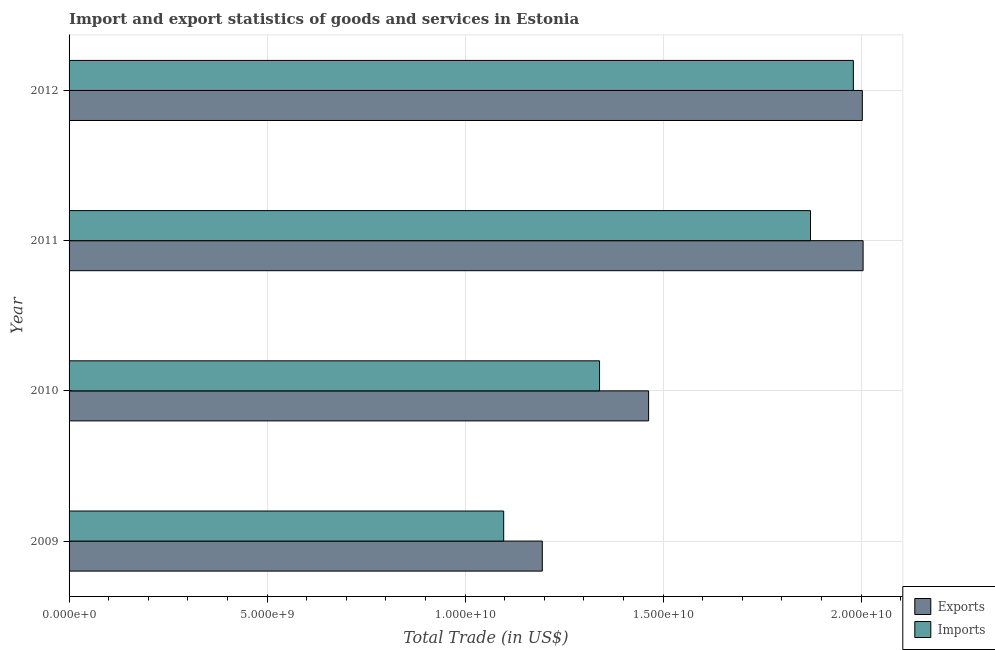How many different coloured bars are there?
Your answer should be very brief. 2. Are the number of bars per tick equal to the number of legend labels?
Your answer should be very brief. Yes. Are the number of bars on each tick of the Y-axis equal?
Make the answer very short. Yes. How many bars are there on the 4th tick from the bottom?
Make the answer very short. 2. In how many cases, is the number of bars for a given year not equal to the number of legend labels?
Your answer should be very brief. 0. What is the imports of goods and services in 2010?
Make the answer very short. 1.34e+1. Across all years, what is the maximum export of goods and services?
Your answer should be very brief. 2.01e+1. Across all years, what is the minimum export of goods and services?
Keep it short and to the point. 1.19e+1. In which year was the imports of goods and services maximum?
Provide a succinct answer. 2012. In which year was the imports of goods and services minimum?
Offer a very short reply. 2009. What is the total imports of goods and services in the graph?
Your answer should be very brief. 6.29e+1. What is the difference between the imports of goods and services in 2009 and that in 2012?
Ensure brevity in your answer.  -8.83e+09. What is the difference between the imports of goods and services in 2009 and the export of goods and services in 2010?
Your response must be concise. -3.66e+09. What is the average imports of goods and services per year?
Give a very brief answer. 1.57e+1. In the year 2009, what is the difference between the imports of goods and services and export of goods and services?
Provide a succinct answer. -9.75e+08. In how many years, is the imports of goods and services greater than 5000000000 US$?
Ensure brevity in your answer.  4. What is the ratio of the imports of goods and services in 2010 to that in 2012?
Provide a succinct answer. 0.68. Is the export of goods and services in 2010 less than that in 2011?
Your answer should be very brief. Yes. Is the difference between the export of goods and services in 2009 and 2010 greater than the difference between the imports of goods and services in 2009 and 2010?
Ensure brevity in your answer.  No. What is the difference between the highest and the second highest export of goods and services?
Offer a terse response. 1.93e+07. What is the difference between the highest and the lowest export of goods and services?
Ensure brevity in your answer.  8.10e+09. In how many years, is the imports of goods and services greater than the average imports of goods and services taken over all years?
Provide a succinct answer. 2. What does the 2nd bar from the top in 2009 represents?
Offer a very short reply. Exports. What does the 2nd bar from the bottom in 2012 represents?
Ensure brevity in your answer.  Imports. Are all the bars in the graph horizontal?
Keep it short and to the point. Yes. Does the graph contain any zero values?
Provide a short and direct response. No. Does the graph contain grids?
Your response must be concise. Yes. How many legend labels are there?
Your answer should be compact. 2. How are the legend labels stacked?
Give a very brief answer. Vertical. What is the title of the graph?
Your answer should be very brief. Import and export statistics of goods and services in Estonia. What is the label or title of the X-axis?
Make the answer very short. Total Trade (in US$). What is the label or title of the Y-axis?
Ensure brevity in your answer.  Year. What is the Total Trade (in US$) of Exports in 2009?
Offer a terse response. 1.19e+1. What is the Total Trade (in US$) in Imports in 2009?
Keep it short and to the point. 1.10e+1. What is the Total Trade (in US$) in Exports in 2010?
Your answer should be compact. 1.46e+1. What is the Total Trade (in US$) of Imports in 2010?
Give a very brief answer. 1.34e+1. What is the Total Trade (in US$) of Exports in 2011?
Give a very brief answer. 2.01e+1. What is the Total Trade (in US$) in Imports in 2011?
Give a very brief answer. 1.87e+1. What is the Total Trade (in US$) in Exports in 2012?
Your answer should be compact. 2.00e+1. What is the Total Trade (in US$) in Imports in 2012?
Keep it short and to the point. 1.98e+1. Across all years, what is the maximum Total Trade (in US$) of Exports?
Give a very brief answer. 2.01e+1. Across all years, what is the maximum Total Trade (in US$) in Imports?
Ensure brevity in your answer.  1.98e+1. Across all years, what is the minimum Total Trade (in US$) of Exports?
Make the answer very short. 1.19e+1. Across all years, what is the minimum Total Trade (in US$) of Imports?
Give a very brief answer. 1.10e+1. What is the total Total Trade (in US$) in Exports in the graph?
Your answer should be compact. 6.67e+1. What is the total Total Trade (in US$) of Imports in the graph?
Keep it short and to the point. 6.29e+1. What is the difference between the Total Trade (in US$) of Exports in 2009 and that in 2010?
Give a very brief answer. -2.68e+09. What is the difference between the Total Trade (in US$) of Imports in 2009 and that in 2010?
Provide a short and direct response. -2.42e+09. What is the difference between the Total Trade (in US$) of Exports in 2009 and that in 2011?
Provide a short and direct response. -8.10e+09. What is the difference between the Total Trade (in US$) of Imports in 2009 and that in 2011?
Give a very brief answer. -7.75e+09. What is the difference between the Total Trade (in US$) of Exports in 2009 and that in 2012?
Provide a succinct answer. -8.08e+09. What is the difference between the Total Trade (in US$) of Imports in 2009 and that in 2012?
Your response must be concise. -8.83e+09. What is the difference between the Total Trade (in US$) in Exports in 2010 and that in 2011?
Give a very brief answer. -5.42e+09. What is the difference between the Total Trade (in US$) in Imports in 2010 and that in 2011?
Offer a terse response. -5.33e+09. What is the difference between the Total Trade (in US$) in Exports in 2010 and that in 2012?
Provide a succinct answer. -5.40e+09. What is the difference between the Total Trade (in US$) of Imports in 2010 and that in 2012?
Give a very brief answer. -6.41e+09. What is the difference between the Total Trade (in US$) in Exports in 2011 and that in 2012?
Your answer should be very brief. 1.93e+07. What is the difference between the Total Trade (in US$) in Imports in 2011 and that in 2012?
Make the answer very short. -1.08e+09. What is the difference between the Total Trade (in US$) of Exports in 2009 and the Total Trade (in US$) of Imports in 2010?
Your answer should be very brief. -1.45e+09. What is the difference between the Total Trade (in US$) of Exports in 2009 and the Total Trade (in US$) of Imports in 2011?
Provide a short and direct response. -6.77e+09. What is the difference between the Total Trade (in US$) in Exports in 2009 and the Total Trade (in US$) in Imports in 2012?
Provide a succinct answer. -7.85e+09. What is the difference between the Total Trade (in US$) of Exports in 2010 and the Total Trade (in US$) of Imports in 2011?
Give a very brief answer. -4.09e+09. What is the difference between the Total Trade (in US$) in Exports in 2010 and the Total Trade (in US$) in Imports in 2012?
Your answer should be compact. -5.17e+09. What is the difference between the Total Trade (in US$) of Exports in 2011 and the Total Trade (in US$) of Imports in 2012?
Keep it short and to the point. 2.46e+08. What is the average Total Trade (in US$) of Exports per year?
Keep it short and to the point. 1.67e+1. What is the average Total Trade (in US$) of Imports per year?
Your answer should be compact. 1.57e+1. In the year 2009, what is the difference between the Total Trade (in US$) in Exports and Total Trade (in US$) in Imports?
Your answer should be compact. 9.75e+08. In the year 2010, what is the difference between the Total Trade (in US$) in Exports and Total Trade (in US$) in Imports?
Make the answer very short. 1.24e+09. In the year 2011, what is the difference between the Total Trade (in US$) of Exports and Total Trade (in US$) of Imports?
Your answer should be very brief. 1.33e+09. In the year 2012, what is the difference between the Total Trade (in US$) of Exports and Total Trade (in US$) of Imports?
Your response must be concise. 2.26e+08. What is the ratio of the Total Trade (in US$) of Exports in 2009 to that in 2010?
Ensure brevity in your answer.  0.82. What is the ratio of the Total Trade (in US$) in Imports in 2009 to that in 2010?
Provide a succinct answer. 0.82. What is the ratio of the Total Trade (in US$) in Exports in 2009 to that in 2011?
Make the answer very short. 0.6. What is the ratio of the Total Trade (in US$) in Imports in 2009 to that in 2011?
Keep it short and to the point. 0.59. What is the ratio of the Total Trade (in US$) in Exports in 2009 to that in 2012?
Your response must be concise. 0.6. What is the ratio of the Total Trade (in US$) of Imports in 2009 to that in 2012?
Your response must be concise. 0.55. What is the ratio of the Total Trade (in US$) in Exports in 2010 to that in 2011?
Offer a very short reply. 0.73. What is the ratio of the Total Trade (in US$) of Imports in 2010 to that in 2011?
Offer a terse response. 0.72. What is the ratio of the Total Trade (in US$) of Exports in 2010 to that in 2012?
Keep it short and to the point. 0.73. What is the ratio of the Total Trade (in US$) of Imports in 2010 to that in 2012?
Offer a very short reply. 0.68. What is the ratio of the Total Trade (in US$) of Imports in 2011 to that in 2012?
Keep it short and to the point. 0.95. What is the difference between the highest and the second highest Total Trade (in US$) of Exports?
Make the answer very short. 1.93e+07. What is the difference between the highest and the second highest Total Trade (in US$) in Imports?
Your response must be concise. 1.08e+09. What is the difference between the highest and the lowest Total Trade (in US$) in Exports?
Your response must be concise. 8.10e+09. What is the difference between the highest and the lowest Total Trade (in US$) in Imports?
Offer a terse response. 8.83e+09. 